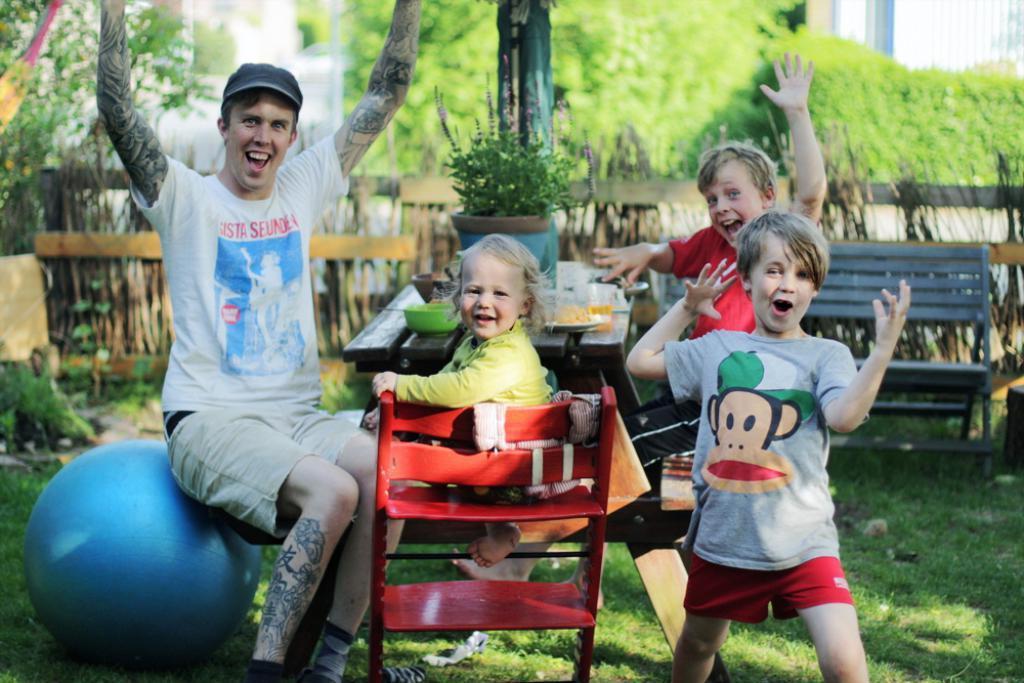Describe this image in one or two sentences. In this image there is a person sat on the ball, beside this person there is a little girl sat on the chair, beside this girl there is a boy standing on the surface of the grass, behind this person there is another person sat on the chair, in front of them there is a table with food item placed on the plate, bowl, glass and a plant pot. In the background there is a wooden fence, bench and trees. 